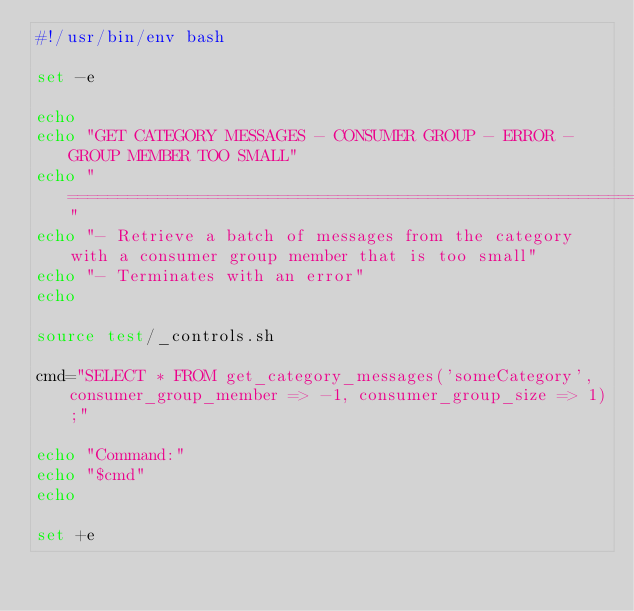Convert code to text. <code><loc_0><loc_0><loc_500><loc_500><_Bash_>#!/usr/bin/env bash

set -e

echo
echo "GET CATEGORY MESSAGES - CONSUMER GROUP - ERROR - GROUP MEMBER TOO SMALL"
echo "======================================================================="
echo "- Retrieve a batch of messages from the category with a consumer group member that is too small"
echo "- Terminates with an error"
echo

source test/_controls.sh

cmd="SELECT * FROM get_category_messages('someCategory', consumer_group_member => -1, consumer_group_size => 1);"

echo "Command:"
echo "$cmd"
echo

set +e</code> 